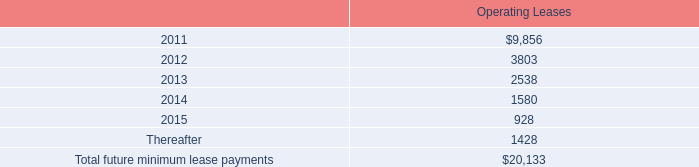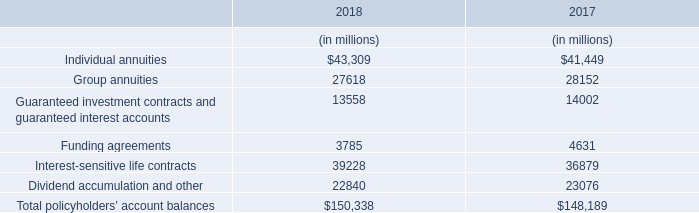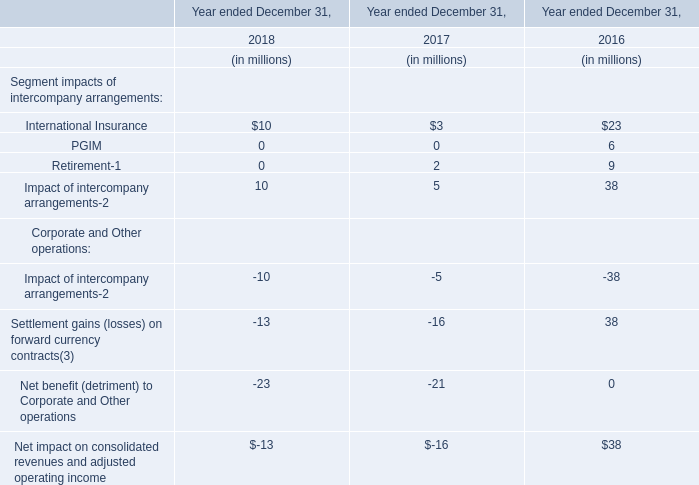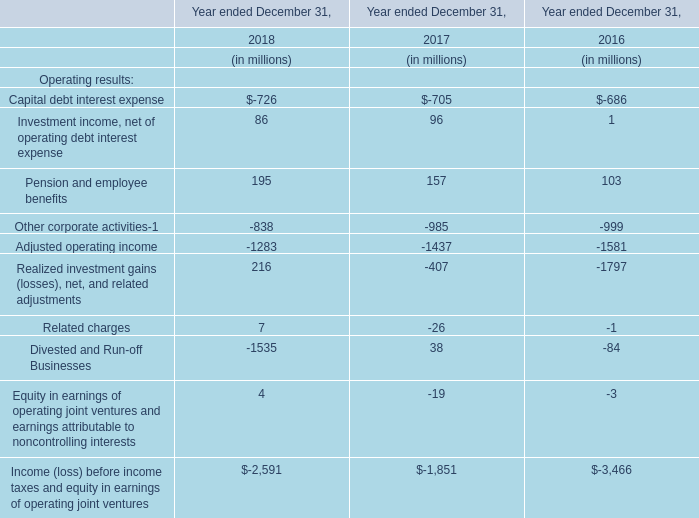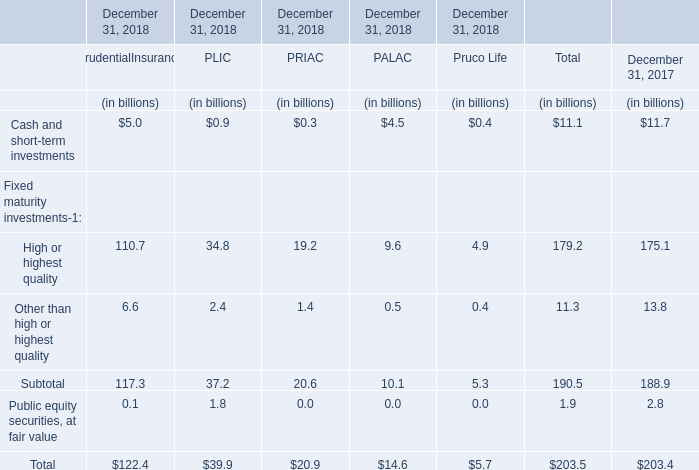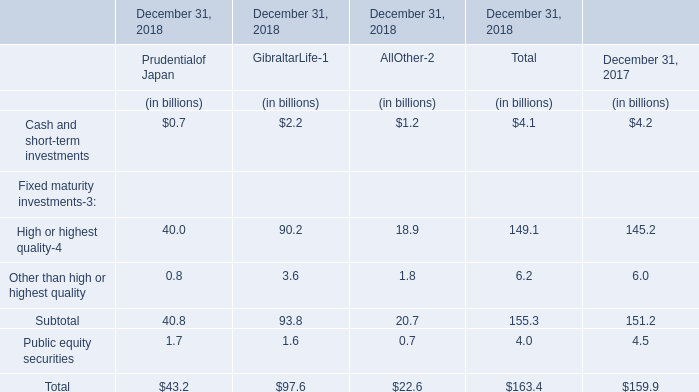What's the current increasing rate of High or highest quality? 
Computations: ((179.2 - 175.1) / 175.1)
Answer: 0.02342. 